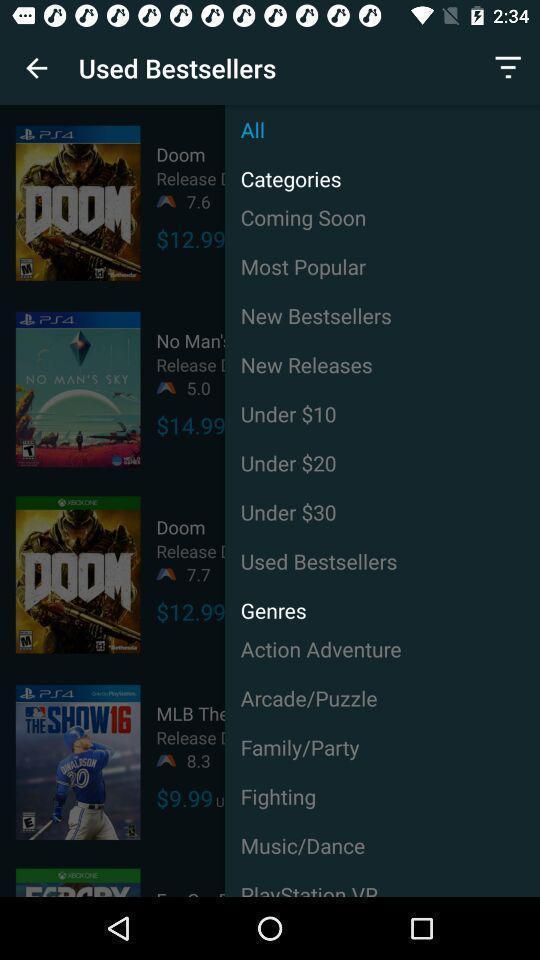Tell me about the visual elements in this screen capture. Screen shows used best sellers in a device. 